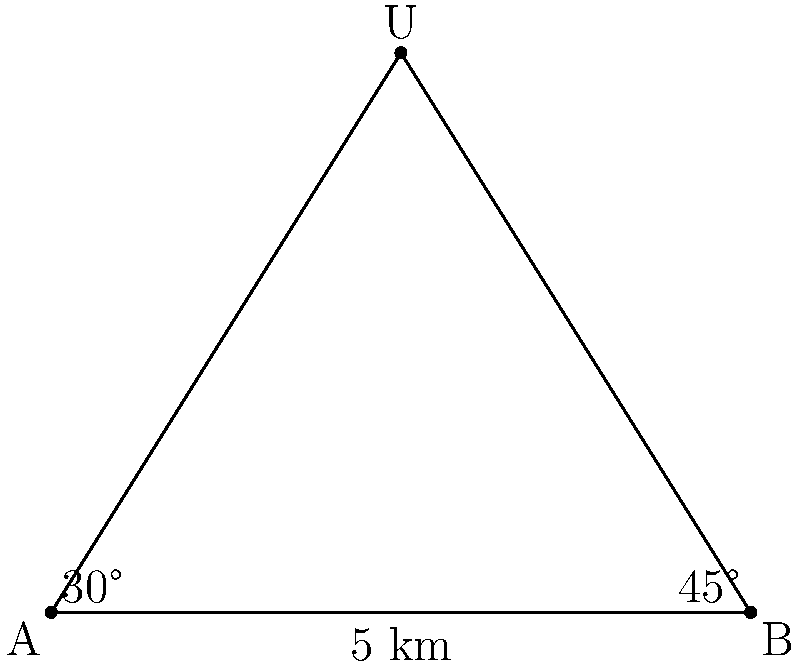Two observers, stationed 5 km apart, spot a UFO in the night sky. Observer A sees the UFO at a 30° angle from the horizontal, while observer B sees it at a 45° angle. Using triangulation methods, determine the altitude of the UFO above the ground. Round your answer to the nearest meter. Let's approach this step-by-step using trigonometry:

1) First, let's define our triangle. The base is the 5 km distance between observers A and B. The UFO forms the third point of the triangle.

2) We can split this into two right-angled triangles. Let's focus on the right triangle formed by observer B, the UFO, and the point directly below the UFO.

3) In this right triangle, we know the angle (45°) and we want to find the height. We can use the tangent function:

   $$\tan(45°) = \frac{\text{height}}{\text{half of base}}$$

4) We know that half of the base is 2.5 km (since the total base is 5 km).

5) Rearranging the equation:

   $$\text{height} = 2.5 \cdot \tan(45°)$$

6) $\tan(45°) = 1$, so:

   $$\text{height} = 2.5 \cdot 1 = 2.5 \text{ km}$$

7) Converting to meters:

   $$2.5 \text{ km} = 2500 \text{ meters}$$

Therefore, the UFO is approximately 2500 meters above the ground.
Answer: 2500 meters 